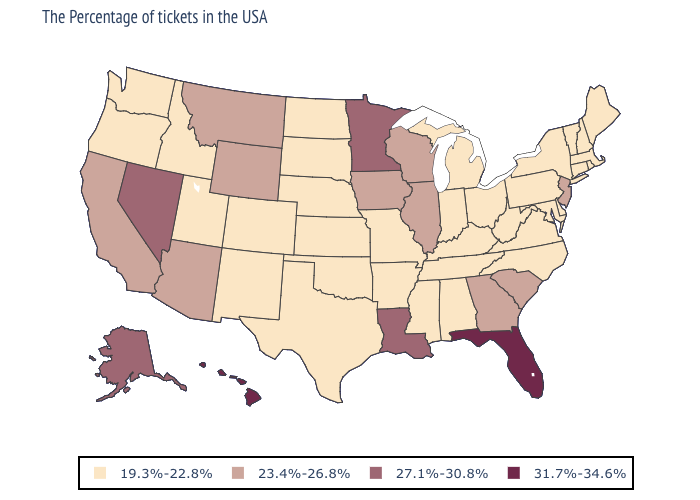Which states have the highest value in the USA?
Short answer required. Florida, Hawaii. What is the lowest value in the MidWest?
Concise answer only. 19.3%-22.8%. Does Hawaii have the same value as Florida?
Short answer required. Yes. What is the value of Texas?
Concise answer only. 19.3%-22.8%. What is the lowest value in states that border Tennessee?
Quick response, please. 19.3%-22.8%. Does Florida have the highest value in the USA?
Keep it brief. Yes. Does the map have missing data?
Quick response, please. No. What is the value of California?
Short answer required. 23.4%-26.8%. How many symbols are there in the legend?
Write a very short answer. 4. Which states hav the highest value in the MidWest?
Be succinct. Minnesota. Which states hav the highest value in the South?
Short answer required. Florida. Does Hawaii have the highest value in the USA?
Concise answer only. Yes. Among the states that border North Carolina , which have the highest value?
Concise answer only. South Carolina, Georgia. Does Utah have the lowest value in the West?
Write a very short answer. Yes. Name the states that have a value in the range 19.3%-22.8%?
Give a very brief answer. Maine, Massachusetts, Rhode Island, New Hampshire, Vermont, Connecticut, New York, Delaware, Maryland, Pennsylvania, Virginia, North Carolina, West Virginia, Ohio, Michigan, Kentucky, Indiana, Alabama, Tennessee, Mississippi, Missouri, Arkansas, Kansas, Nebraska, Oklahoma, Texas, South Dakota, North Dakota, Colorado, New Mexico, Utah, Idaho, Washington, Oregon. 